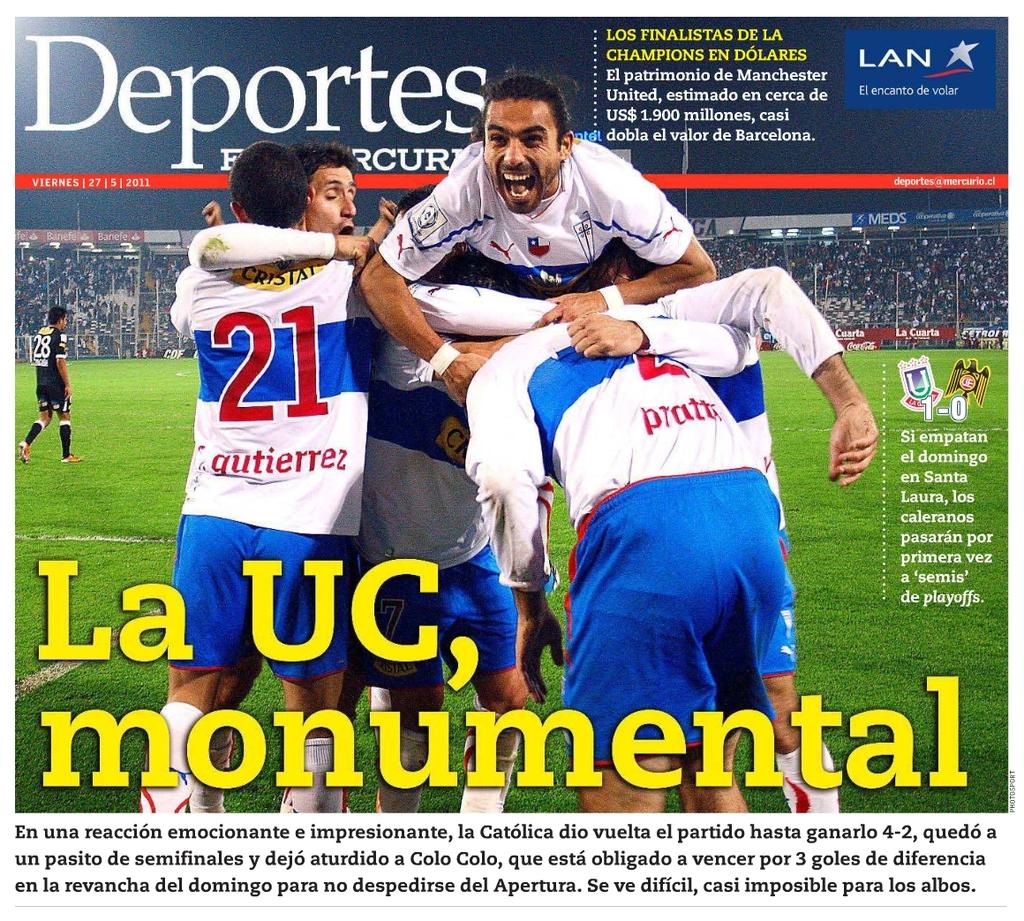What is the name of the magazine?
Give a very brief answer. Deportes. 